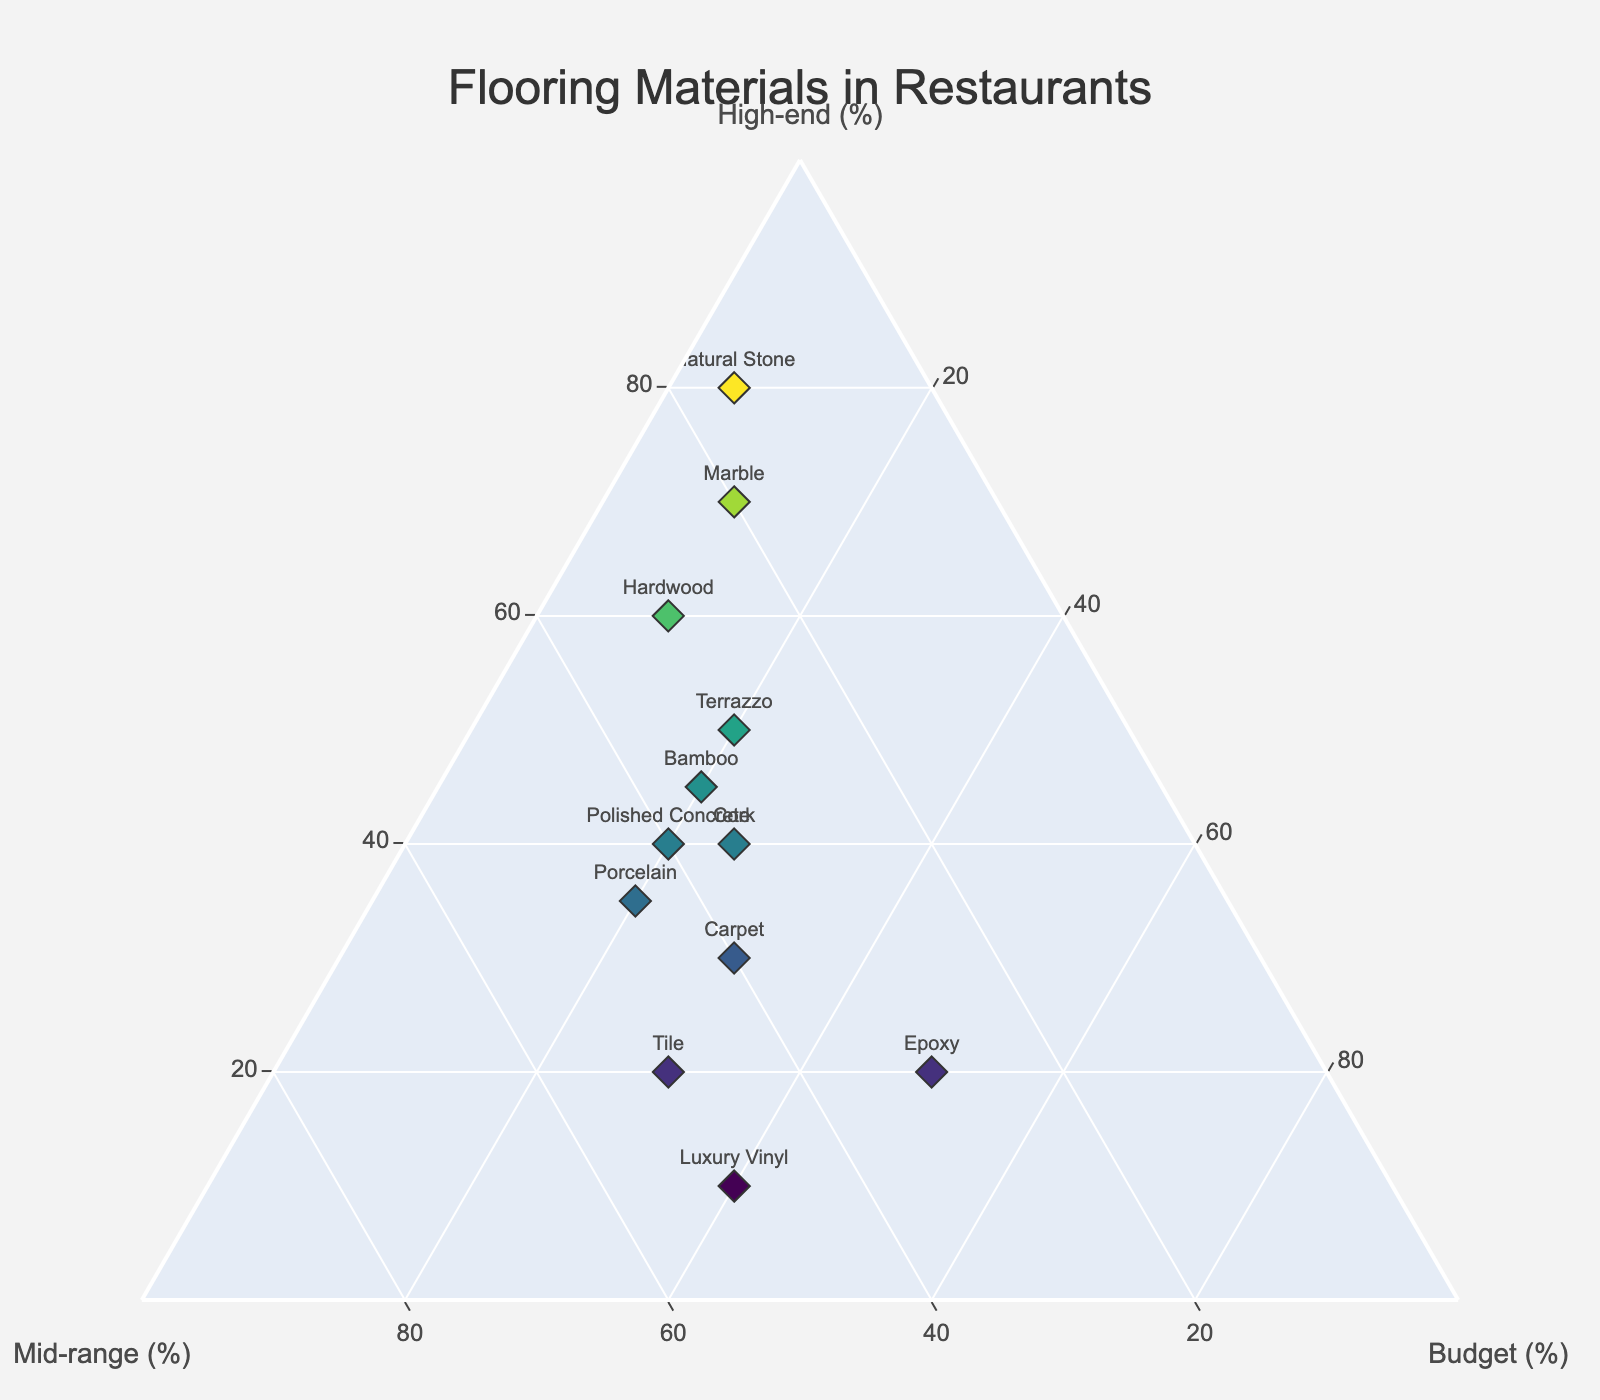What is the title of the plot? The title is the text most prominently displayed at the top of the plot. It provides a quick insight into what the plot is about.
Answer: Flooring Materials in Restaurants How many different flooring materials are represented in the plot? Count the distinct labels for different flooring materials displayed near the markers on the plot. Each unique label corresponds to a different type of flooring material.
Answer: 12 Which flooring material is most commonly used in high-end restaurants? Identify the material with the highest value on the 'High-end' axis. This value shows the percentage of use in high-end restaurants.
Answer: Natural Stone Which material has equal representation in mid-range and budget restaurants? Look for a material where the percentage values for 'Mid-range' and 'Budget' are the same. Check the corresponding values on both axes of the ternary plot for equality.
Answer: Epoxy What flooring material has the smallest combined usage across all restaurant types (high-end, mid-range, and budget)? Sum the values across high-end, mid-range, and budget for each material. The material with the smallest total sum has the smallest combined usage.
Answer: Luxury Vinyl Compare the use of Hardwood and Marble in budget restaurants. Which one is used more? Compare the 'Budget' percentages for Hardwood and Marble. Identify which has the higher value on the ternary plot for budget restaurants.
Answer: Hardwood Which material shows a balanced usage (equal percentages) among high-end, mid-range, and budget restaurants? Find any material where the points lie near the center of the ternary plot, indicating equal distribution among high-end, mid-range, and budget categories.
Answer: Polished Concrete Which material is least used in high-end restaurants? Identify the material with the smallest value on the 'High-end' axis. This value represents the percentage used in high-end restaurants.
Answer: Luxury Vinyl What is the average percentage use of Cork across all three types of restaurants? Calculate the average by summing the percentages of 'High-end', 'Mid-range', and 'Budget' for Cork, then divide by three. The formula is (40 + 35 + 25) / 3.
Answer: 33.33 